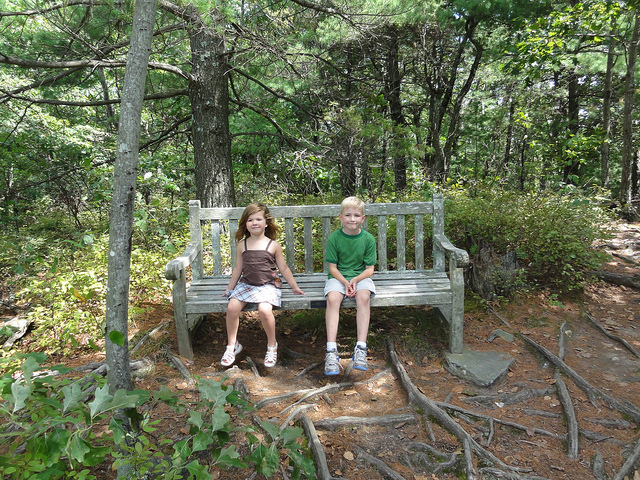Imagine yourself sitting on this bench. What thoughts or feelings does it evoke? Sitting on this bench, surrounded by the lush forest, I feel a profound sense of tranquility and connection with nature. The gentle rustle of leaves and distant chirping of birds create a soothing soundtrack that eases my mind. It's a moment of stillness and reflection, allowing me to appreciate the simple beauty of the world around me. 